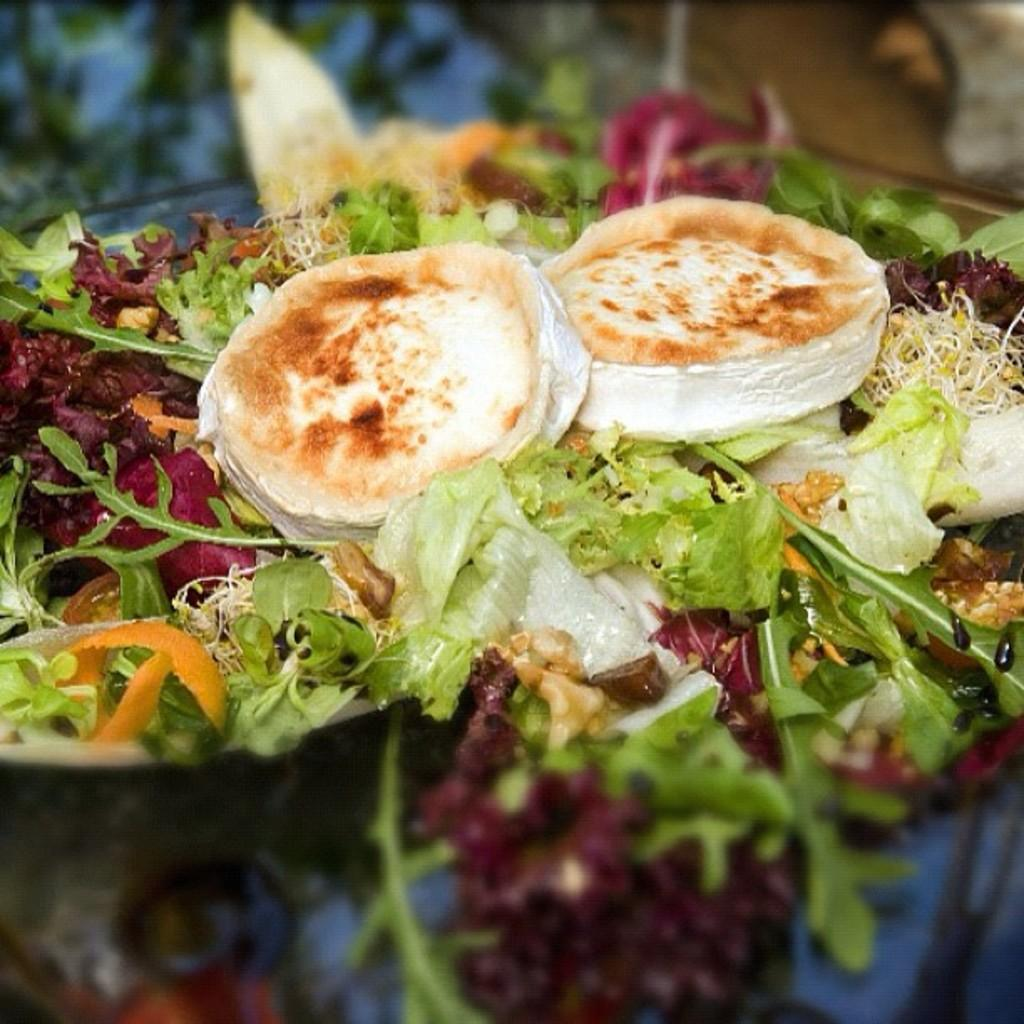What type of food can be seen in the image? The image contains green vegetables and sprouts, which are edible things. Can you describe the vegetables in the image? The green vegetables in the image are not specified, but they are a type of edible plant. What else is present in the image besides the vegetables? There are sprouts in the image. What time does the clock show in the image? There is no clock present in the image. How many houses are visible in the image? There are no houses visible in the image. Can you describe the cow in the image? There is no cow present in the image. 